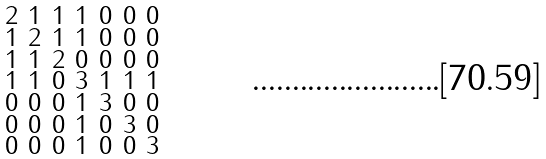<formula> <loc_0><loc_0><loc_500><loc_500>\begin{smallmatrix} 2 & 1 & 1 & 1 & 0 & 0 & 0 \\ 1 & 2 & 1 & 1 & 0 & 0 & 0 \\ 1 & 1 & 2 & 0 & 0 & 0 & 0 \\ 1 & 1 & 0 & 3 & 1 & 1 & 1 \\ 0 & 0 & 0 & 1 & 3 & 0 & 0 \\ 0 & 0 & 0 & 1 & 0 & 3 & 0 \\ 0 & 0 & 0 & 1 & 0 & 0 & 3 \end{smallmatrix}</formula> 